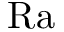Convert formula to latex. <formula><loc_0><loc_0><loc_500><loc_500>R a</formula> 